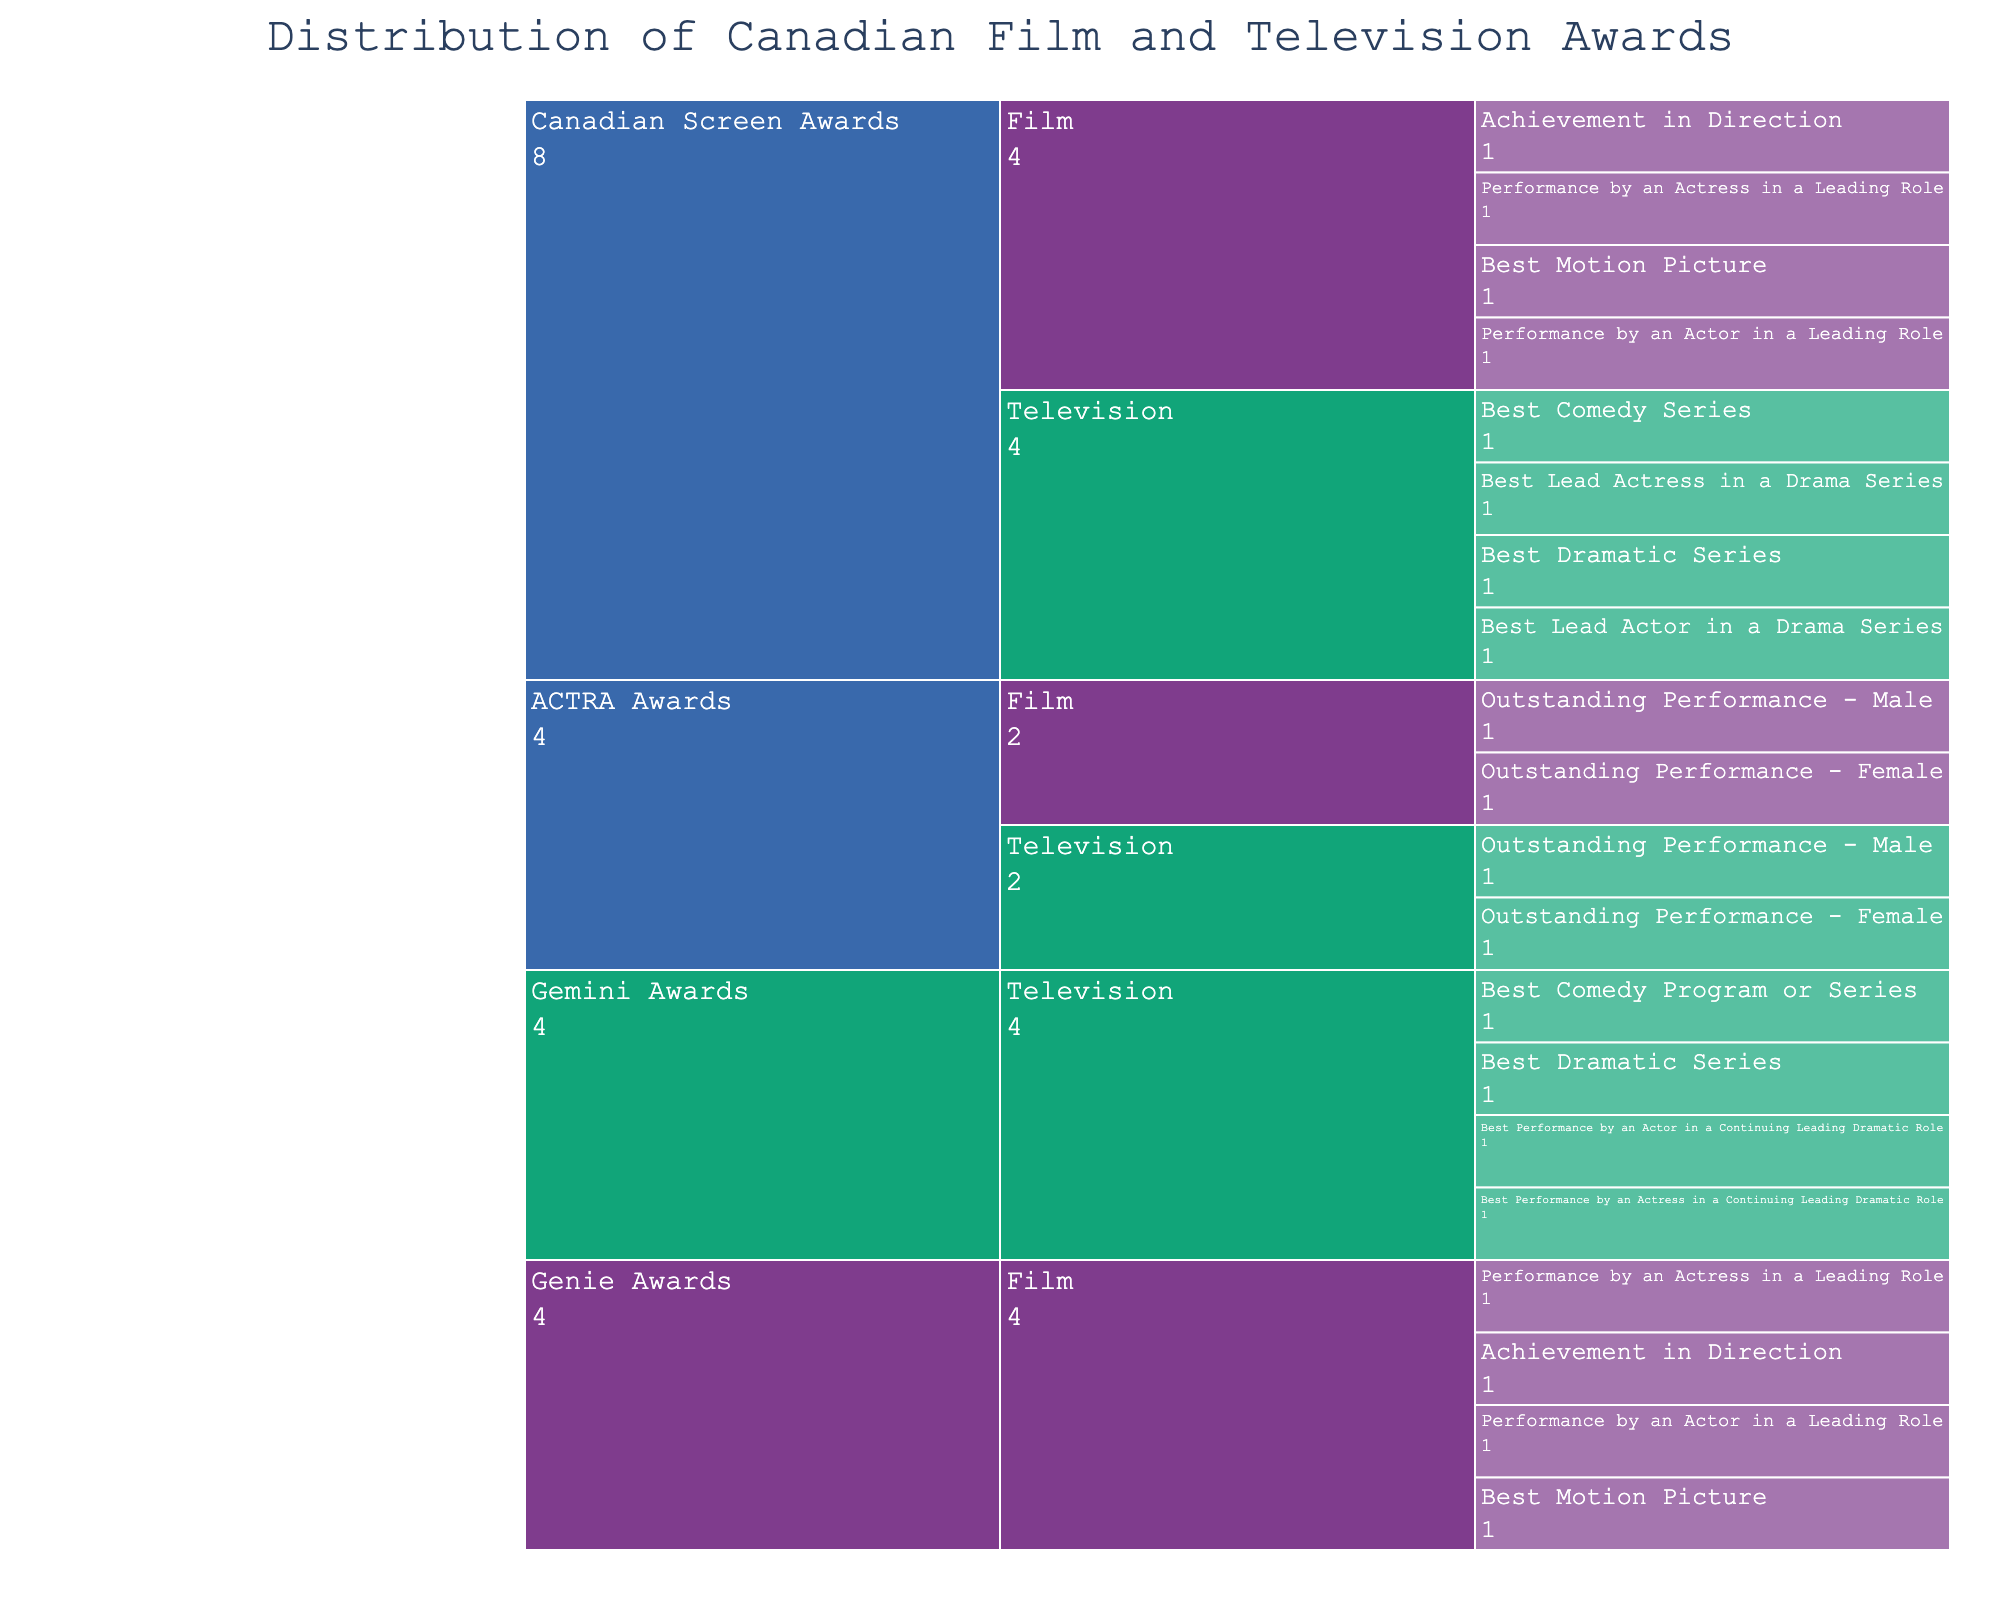What's the total count of awards for the Canadian Screen Awards? Look at all the elements labeled under "Canadian Screen Awards" in the figure. There are 8 subcategories listed each with a count of 1, therefore the total is 8.
Answer: 8 How many awards are there in the Film subcategory for Genie Awards? Look under the "Genie Awards" category and count all the elements under the "Film" subcategory. There are 4 awards listed.
Answer: 4 Which category has more subcategories, Gemini Awards or ACTRA Awards? Compare the subcategories listed under "Gemini Awards" and "ACTRA Awards". The "Gemini Awards" has 1 subcategory (Television) and "ACTRA Awards" has 2 subcategories (Television and Film).
Answer: ACTRA Awards Is the count of awards for Best Motion Picture the same in both Canadian Screen Awards and Genie Awards? Look at both the "Canadian Screen Awards" and "Genie Awards" categories, and check the subcategory "Film" for the award "Best Motion Picture". Both categories have the award listed only once each.
Answer: Yes Which subcategory has the most awards under the Canadian Screen Awards? Within the "Canadian Screen Awards" category, compare the counts of awards under "Film" and "Television". Both "Film" and "Television" have 4 awards each, so they are equal.
Answer: Film and Television How many different categories are represented in the dataset? Observe the outermost labels for categories. There are 4 different categories: Canadian Screen Awards, Gemini Awards, Genie Awards, and ACTRA Awards.
Answer: 4 Which category contains the award for "Outstanding Performance - Male"? Look for the award "Outstanding Performance - Male" and check the category it falls under. It is listed under "ACTRA Awards" for both Film and Television subcategories.
Answer: ACTRA Awards Between Film and Television, which subcategory has more total awards in the entire dataset? Count the total number of awards listed under "Film" and "Television" across all categories. Film: 4 (CSA) + 4 (Genie) + 2 (ACTRA) = 10, Television: 4 (CSA) + 4 (Gemini) + 2 (ACTRA) = 10. Both subcategories have the same count of total awards.
Answer: Both are equal What are the awards within the Film subcategory of ACTRA Awards? Look under the "ACTRA Awards" category, then the "Film" subcategory. The awards listed are "Outstanding Performance - Female" and "Outstanding Performance - Male".
Answer: Outstanding Performance - Female and Outstanding Performance - Male 